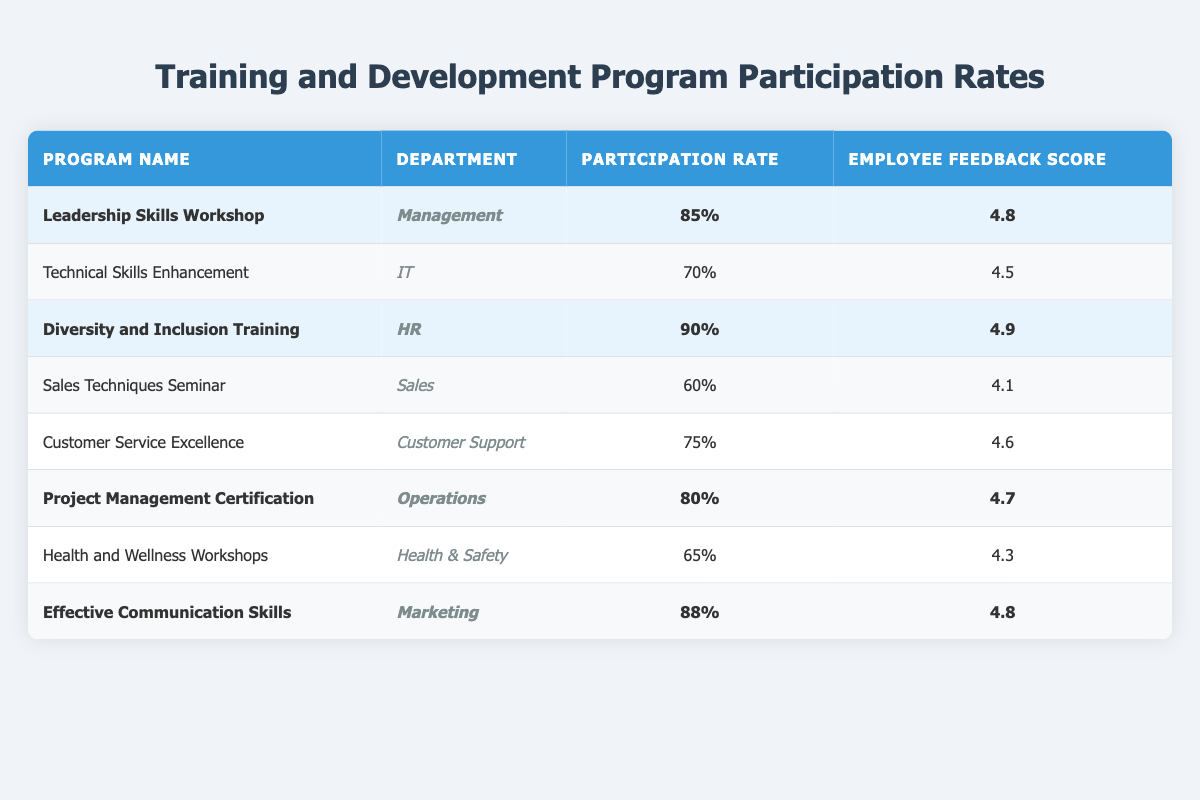What is the participation rate for the "Diversity and Inclusion Training"? The table lists the "Diversity and Inclusion Training" program, which shows a participation rate of 90%.
Answer: 90% Which program has the highest employee feedback score? By comparing the scores in the table, "Diversity and Inclusion Training" has the highest score of 4.9.
Answer: 4.9 How many programs have a participation rate above 80%? The table lists four programs with participation rates above 80%: "Leadership Skills Workshop" (85%), "Diversity and Inclusion Training" (90%), "Project Management Certification" (80%), and "Effective Communication Skills" (88%). Therefore, there are four programs.
Answer: 4 Is there a program in the Sales department among the highlighted programs? In the highlighted section of the table, there is no program listed under the Sales department; the highlighted programs are from Management, HR, Operations, and Marketing.
Answer: No What is the average feedback score for the programs with highlighted participation rates? The scores of the highlighted programs are 4.8 (Leadership Skills Workshop), 4.9 (Diversity and Inclusion Training), 4.7 (Project Management Certification), and 4.8 (Effective Communication Skills). The average is calculated as (4.8 + 4.9 + 4.7 + 4.8) / 4 = 4.8.
Answer: 4.8 Which department has the highest participation rate in their training program? The "Diversity and Inclusion Training" program from the HR department has the highest participation rate at 90%.
Answer: HR How do the participation rates of the IT and Sales departments compare? The participation rate for IT (Technical Skills Enhancement) is 70%, while the Sales department (Sales Techniques Seminar) has a participation rate of 60%. Hence, IT has a higher participation rate than Sales.
Answer: IT has a higher rate What is the difference in participation rates between the highest and lowest programs? The highest participation rate is 90% (Diversity and Inclusion Training), and the lowest is 60% (Sales Techniques Seminar). The difference is calculated as 90% - 60% = 30%.
Answer: 30% 